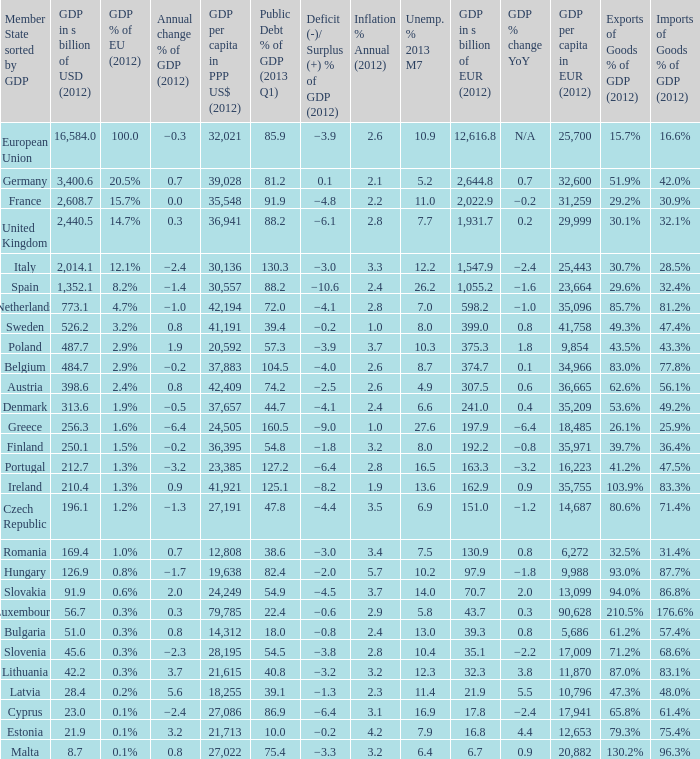Can you parse all the data within this table? {'header': ['Member State sorted by GDP', 'GDP in s billion of USD (2012)', 'GDP % of EU (2012)', 'Annual change % of GDP (2012)', 'GDP per capita in PPP US$ (2012)', 'Public Debt % of GDP (2013 Q1)', 'Deficit (-)/ Surplus (+) % of GDP (2012)', 'Inflation % Annual (2012)', 'Unemp. % 2013 M7', 'GDP in s billion of EUR (2012)', 'GDP % change YoY', 'GDP per capita in EUR (2012)', 'Exports of Goods % of GDP (2012)', 'Imports of Goods % of GDP (2012)'], 'rows': [['European Union', '16,584.0', '100.0', '−0.3', '32,021', '85.9', '−3.9', '2.6', '10.9', '12,616.8', 'N/A', '25,700', '15.7%', '16.6%'], ['Germany', '3,400.6', '20.5%', '0.7', '39,028', '81.2', '0.1', '2.1', '5.2', '2,644.8', '0.7', '32,600', '51.9%', '42.0%'], ['France', '2,608.7', '15.7%', '0.0', '35,548', '91.9', '−4.8', '2.2', '11.0', '2,022.9', '−0.2', '31,259', '29.2%', '30.9%'], ['United Kingdom', '2,440.5', '14.7%', '0.3', '36,941', '88.2', '−6.1', '2.8', '7.7', '1,931.7', '0.2', '29,999', '30.1%', '32.1%'], ['Italy', '2,014.1', '12.1%', '−2.4', '30,136', '130.3', '−3.0', '3.3', '12.2', '1,547.9', '−2.4', '25,443', '30.7%', '28.5%'], ['Spain', '1,352.1', '8.2%', '−1.4', '30,557', '88.2', '−10.6', '2.4', '26.2', '1,055.2', '−1.6', '23,664', '29.6%', '32.4%'], ['Netherlands', '773.1', '4.7%', '−1.0', '42,194', '72.0', '−4.1', '2.8', '7.0', '598.2', '−1.0', '35,096', '85.7%', '81.2%'], ['Sweden', '526.2', '3.2%', '0.8', '41,191', '39.4', '−0.2', '1.0', '8.0', '399.0', '0.8', '41,758', '49.3%', '47.4%'], ['Poland', '487.7', '2.9%', '1.9', '20,592', '57.3', '−3.9', '3.7', '10.3', '375.3', '1.8', '9,854', '43.5%', '43.3%'], ['Belgium', '484.7', '2.9%', '−0.2', '37,883', '104.5', '−4.0', '2.6', '8.7', '374.7', '0.1', '34,966', '83.0%', '77.8%'], ['Austria', '398.6', '2.4%', '0.8', '42,409', '74.2', '−2.5', '2.6', '4.9', '307.5', '0.6', '36,665', '62.6%', '56.1%'], ['Denmark', '313.6', '1.9%', '−0.5', '37,657', '44.7', '−4.1', '2.4', '6.6', '241.0', '0.4', '35,209', '53.6%', '49.2%'], ['Greece', '256.3', '1.6%', '−6.4', '24,505', '160.5', '−9.0', '1.0', '27.6', '197.9', '−6.4', '18,485', '26.1%', '25.9%'], ['Finland', '250.1', '1.5%', '−0.2', '36,395', '54.8', '−1.8', '3.2', '8.0', '192.2', '−0.8', '35,971', '39.7%', '36.4%'], ['Portugal', '212.7', '1.3%', '−3.2', '23,385', '127.2', '−6.4', '2.8', '16.5', '163.3', '−3.2', '16,223', '41.2%', '47.5%'], ['Ireland', '210.4', '1.3%', '0.9', '41,921', '125.1', '−8.2', '1.9', '13.6', '162.9', '0.9', '35,755', '103.9%', '83.3%'], ['Czech Republic', '196.1', '1.2%', '−1.3', '27,191', '47.8', '−4.4', '3.5', '6.9', '151.0', '−1.2', '14,687', '80.6%', '71.4%'], ['Romania', '169.4', '1.0%', '0.7', '12,808', '38.6', '−3.0', '3.4', '7.5', '130.9', '0.8', '6,272', '32.5%', '31.4%'], ['Hungary', '126.9', '0.8%', '−1.7', '19,638', '82.4', '−2.0', '5.7', '10.2', '97.9', '−1.8', '9,988', '93.0%', '87.7%'], ['Slovakia', '91.9', '0.6%', '2.0', '24,249', '54.9', '−4.5', '3.7', '14.0', '70.7', '2.0', '13,099', '94.0%', '86.8%'], ['Luxembourg', '56.7', '0.3%', '0.3', '79,785', '22.4', '−0.6', '2.9', '5.8', '43.7', '0.3', '90,628', '210.5%', '176.6%'], ['Bulgaria', '51.0', '0.3%', '0.8', '14,312', '18.0', '−0.8', '2.4', '13.0', '39.3', '0.8', '5,686', '61.2%', '57.4%'], ['Slovenia', '45.6', '0.3%', '−2.3', '28,195', '54.5', '−3.8', '2.8', '10.4', '35.1', '−2.2', '17,009', '71.2%', '68.6%'], ['Lithuania', '42.2', '0.3%', '3.7', '21,615', '40.8', '−3.2', '3.2', '12.3', '32.3', '3.8', '11,870', '87.0%', '83.1%'], ['Latvia', '28.4', '0.2%', '5.6', '18,255', '39.1', '−1.3', '2.3', '11.4', '21.9', '5.5', '10,796', '47.3%', '48.0%'], ['Cyprus', '23.0', '0.1%', '−2.4', '27,086', '86.9', '−6.4', '3.1', '16.9', '17.8', '−2.4', '17,941', '65.8%', '61.4%'], ['Estonia', '21.9', '0.1%', '3.2', '21,713', '10.0', '−0.2', '4.2', '7.9', '16.8', '4.4', '12,653', '79.3%', '75.4%'], ['Malta', '8.7', '0.1%', '0.8', '27,022', '75.4', '−3.3', '3.2', '6.4', '6.7', '0.9', '20,882', '130.2%', '96.3%']]} What is the average public debt % of GDP in 2013 Q1 of the country with a member slate sorted by GDP of Czech Republic and a GDP per capita in PPP US dollars in 2012 greater than 27,191? None. 